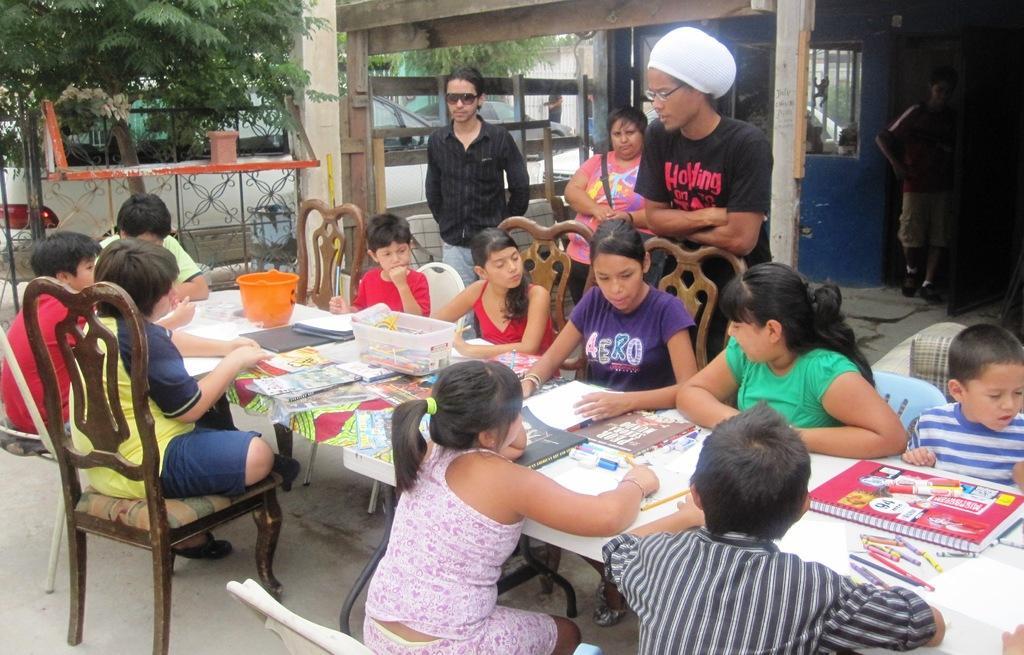Please provide a concise description of this image. In this picture There are few people sitting on the chair. These four people standing. There is a table. On the table we can see Book,Bucket,basket,Pencils. We can see chairs. There are trees. On the background we can see wall,window. This person wore cap. This is floor. 